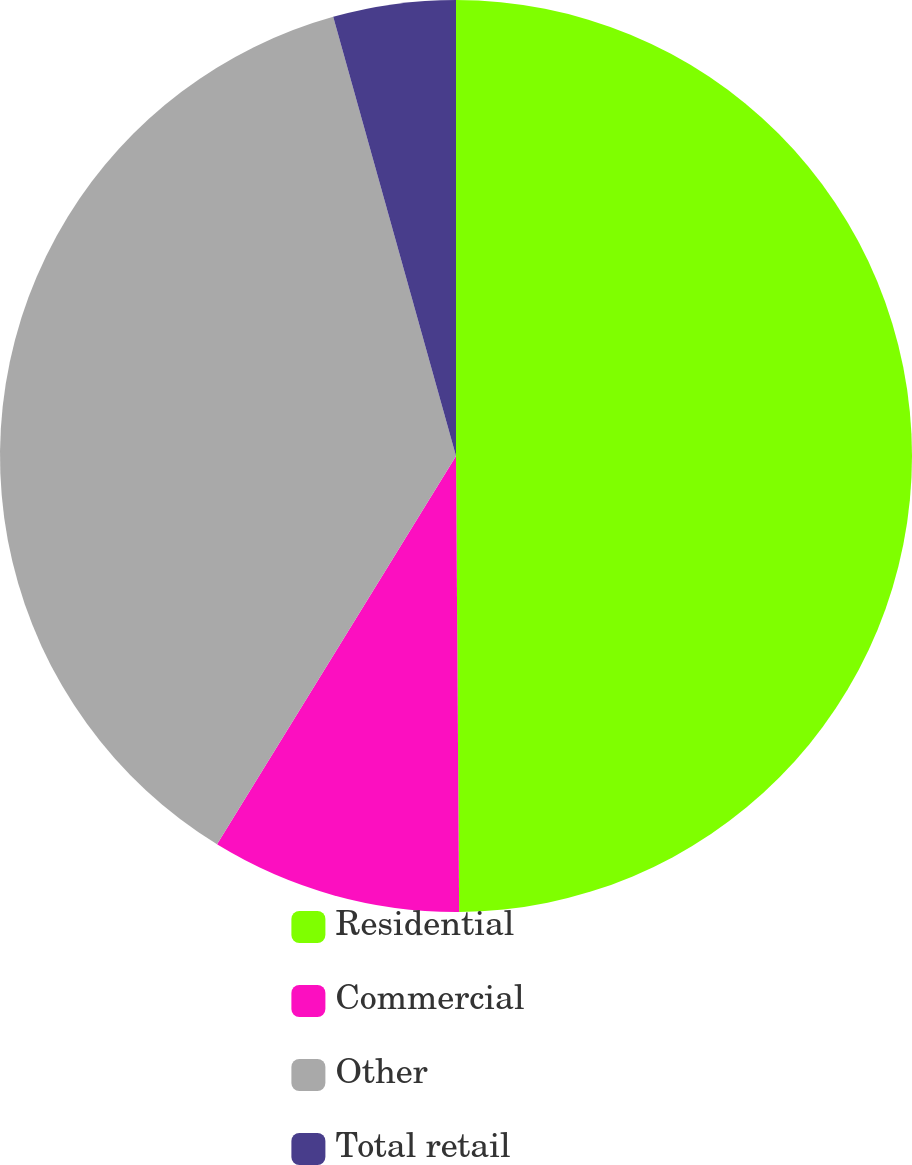Convert chart to OTSL. <chart><loc_0><loc_0><loc_500><loc_500><pie_chart><fcel>Residential<fcel>Commercial<fcel>Other<fcel>Total retail<nl><fcel>49.89%<fcel>8.89%<fcel>36.88%<fcel>4.34%<nl></chart> 